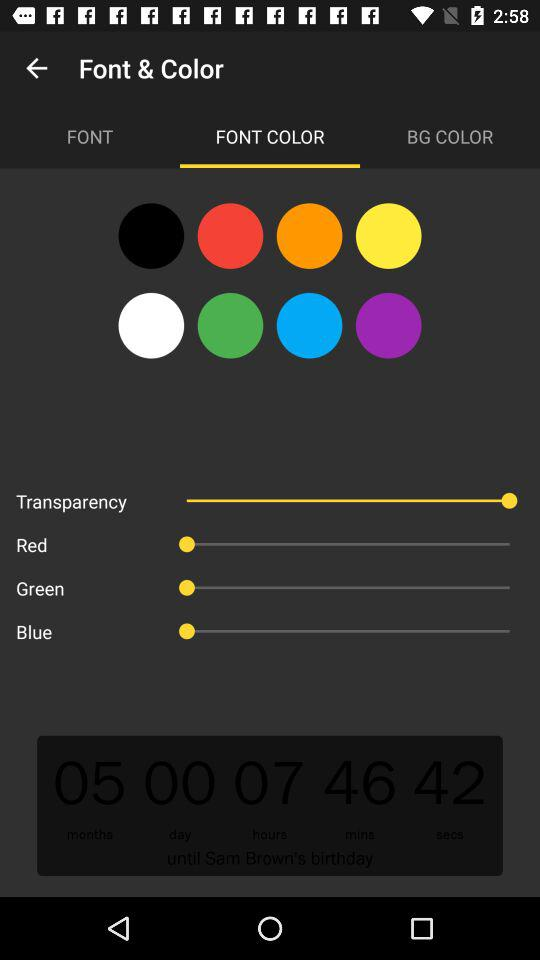Which tab is selected for "Font & Color"? The selected tab is "FONT COLOR". 